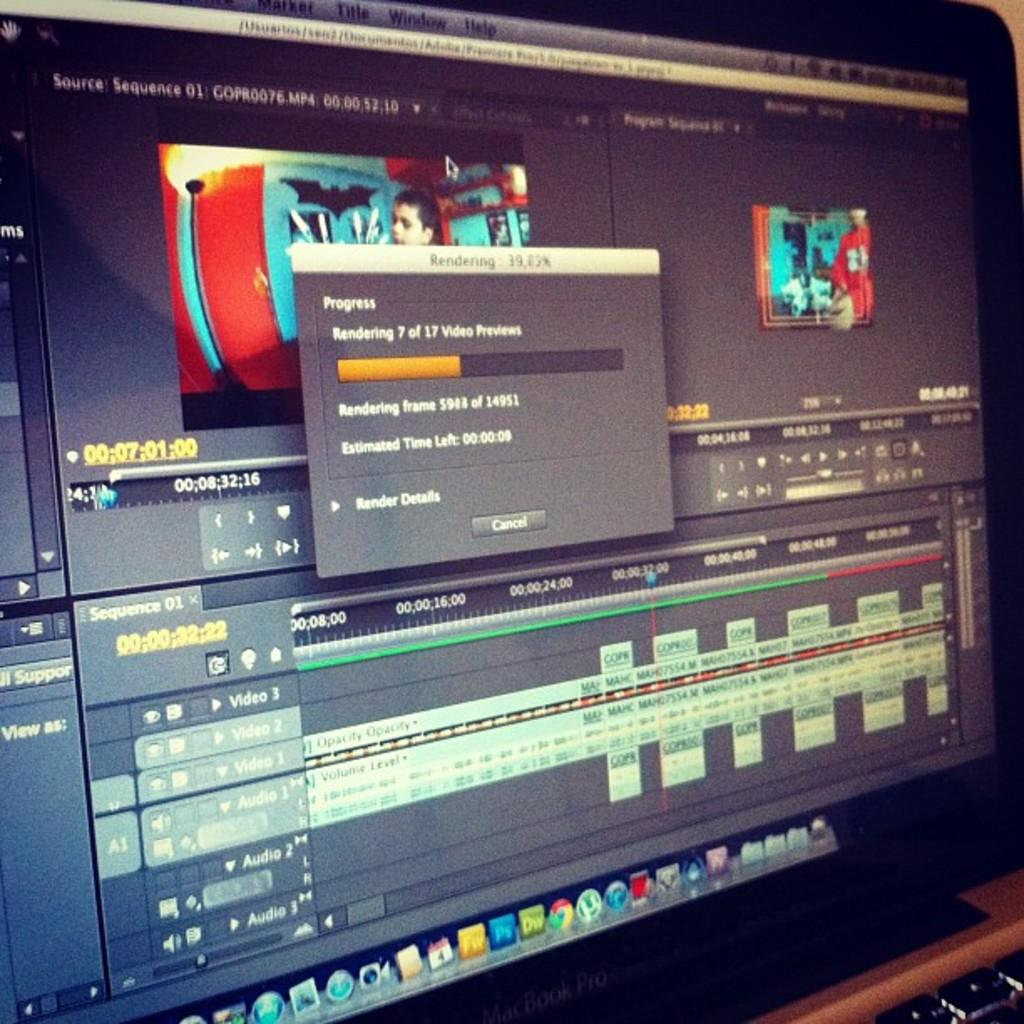<image>
Write a terse but informative summary of the picture. a computer screen with a box stated rendering in grey and black at the forefront 